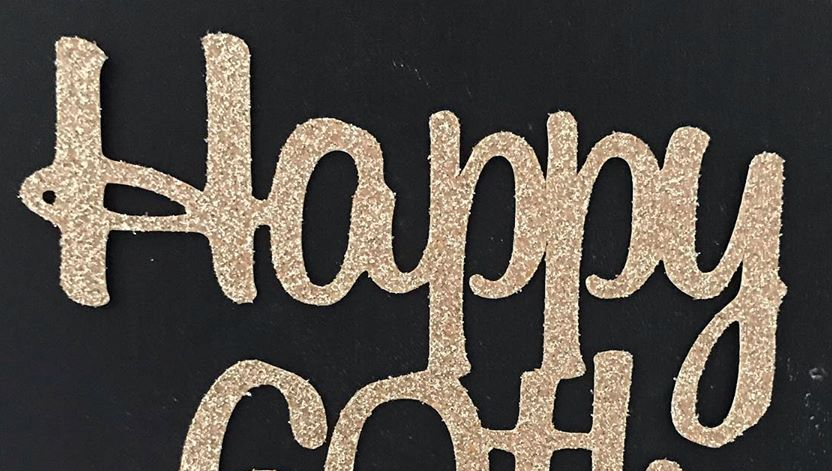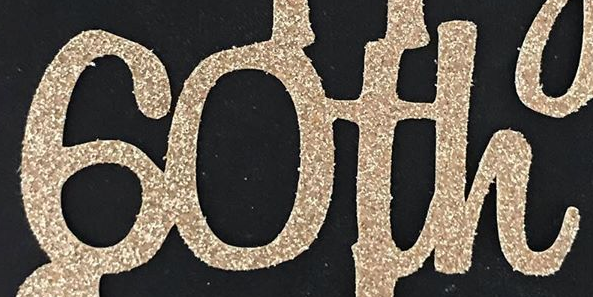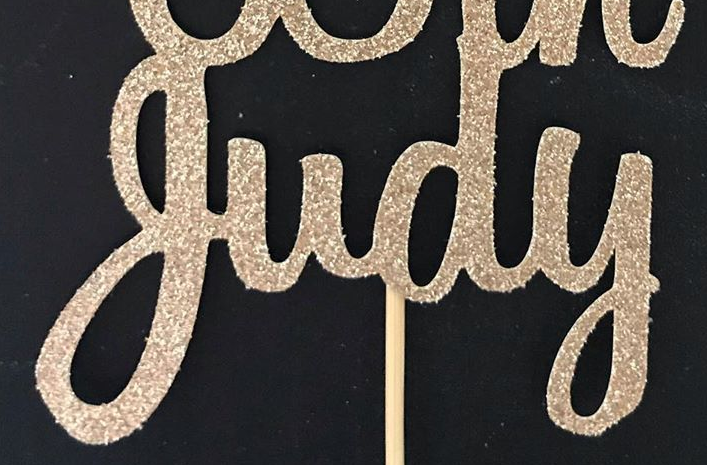What words can you see in these images in sequence, separated by a semicolon? Happy; 60th; judy 